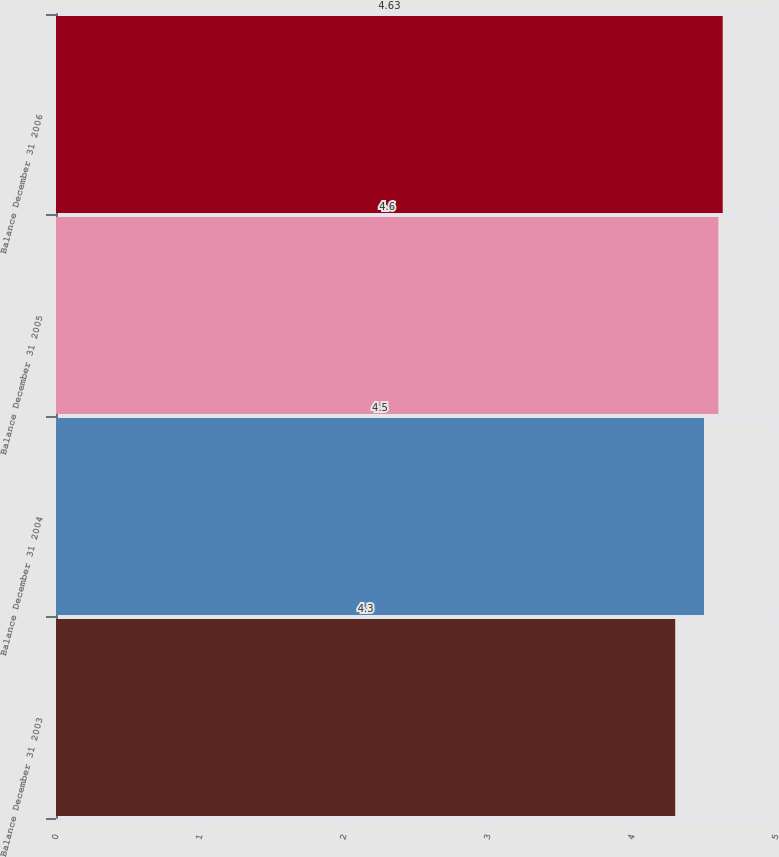<chart> <loc_0><loc_0><loc_500><loc_500><bar_chart><fcel>Balance December 31 2003<fcel>Balance December 31 2004<fcel>Balance December 31 2005<fcel>Balance December 31 2006<nl><fcel>4.3<fcel>4.5<fcel>4.6<fcel>4.63<nl></chart> 